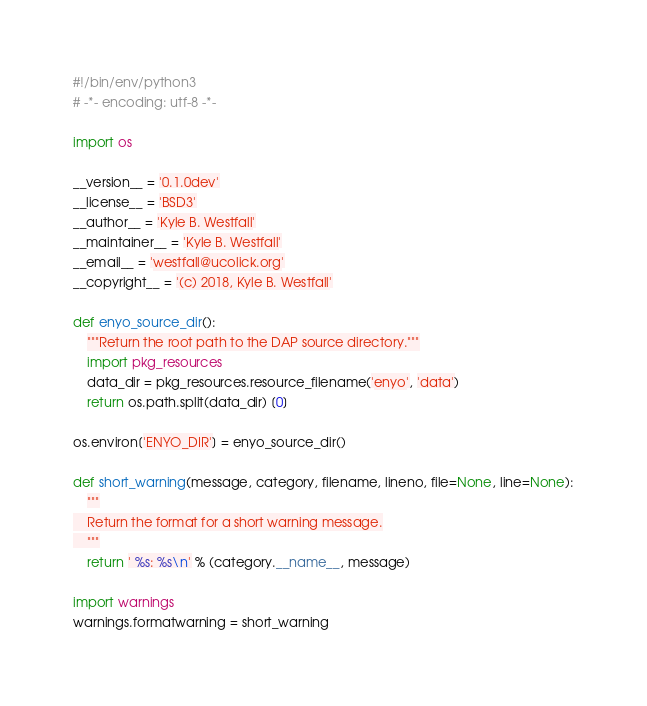Convert code to text. <code><loc_0><loc_0><loc_500><loc_500><_Python_>#!/bin/env/python3
# -*- encoding: utf-8 -*-

import os

__version__ = '0.1.0dev'
__license__ = 'BSD3'
__author__ = 'Kyle B. Westfall'
__maintainer__ = 'Kyle B. Westfall'
__email__ = 'westfall@ucolick.org'
__copyright__ = '(c) 2018, Kyle B. Westfall'

def enyo_source_dir():
    """Return the root path to the DAP source directory."""
    import pkg_resources
    data_dir = pkg_resources.resource_filename('enyo', 'data')
    return os.path.split(data_dir) [0]

os.environ['ENYO_DIR'] = enyo_source_dir()

def short_warning(message, category, filename, lineno, file=None, line=None):
    """
    Return the format for a short warning message.
    """
    return ' %s: %s\n' % (category.__name__, message)

import warnings
warnings.formatwarning = short_warning
</code> 